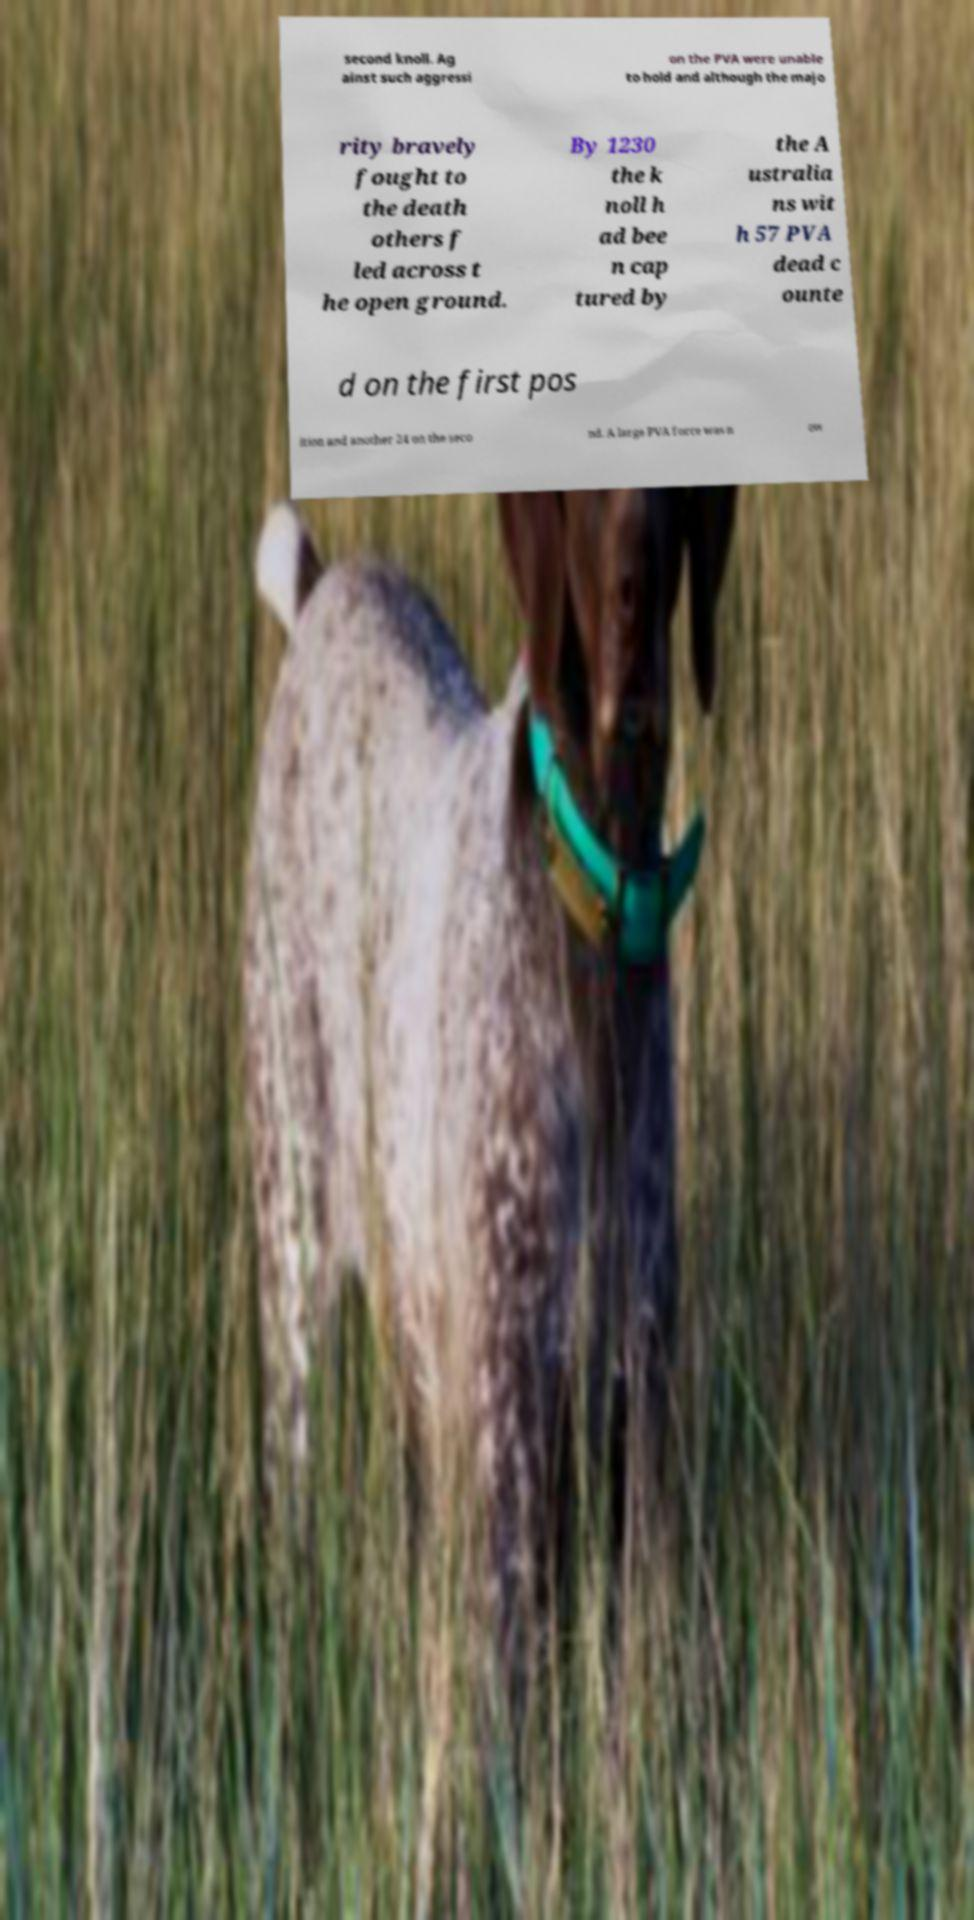Please identify and transcribe the text found in this image. second knoll. Ag ainst such aggressi on the PVA were unable to hold and although the majo rity bravely fought to the death others f led across t he open ground. By 1230 the k noll h ad bee n cap tured by the A ustralia ns wit h 57 PVA dead c ounte d on the first pos ition and another 24 on the seco nd. A large PVA force was n ow 